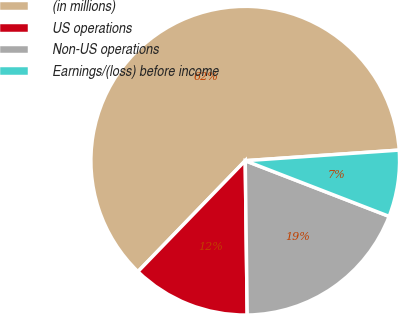Convert chart to OTSL. <chart><loc_0><loc_0><loc_500><loc_500><pie_chart><fcel>(in millions)<fcel>US operations<fcel>Non-US operations<fcel>Earnings/(loss) before income<nl><fcel>61.67%<fcel>12.44%<fcel>18.92%<fcel>6.97%<nl></chart> 